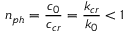<formula> <loc_0><loc_0><loc_500><loc_500>n _ { p h } = \frac { c _ { 0 } } { c _ { c r } } = \frac { k _ { c r } } { k _ { 0 } } < 1</formula> 